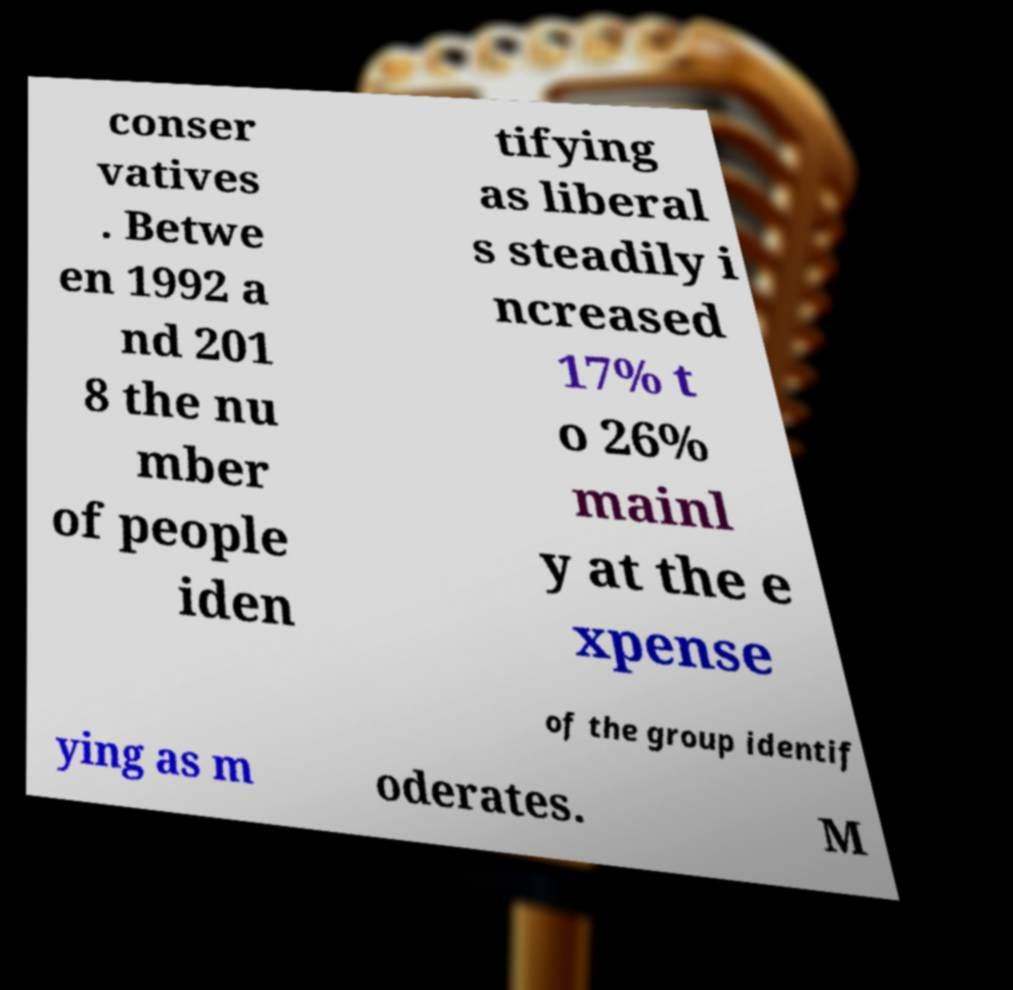What messages or text are displayed in this image? I need them in a readable, typed format. conser vatives . Betwe en 1992 a nd 201 8 the nu mber of people iden tifying as liberal s steadily i ncreased 17% t o 26% mainl y at the e xpense of the group identif ying as m oderates. M 